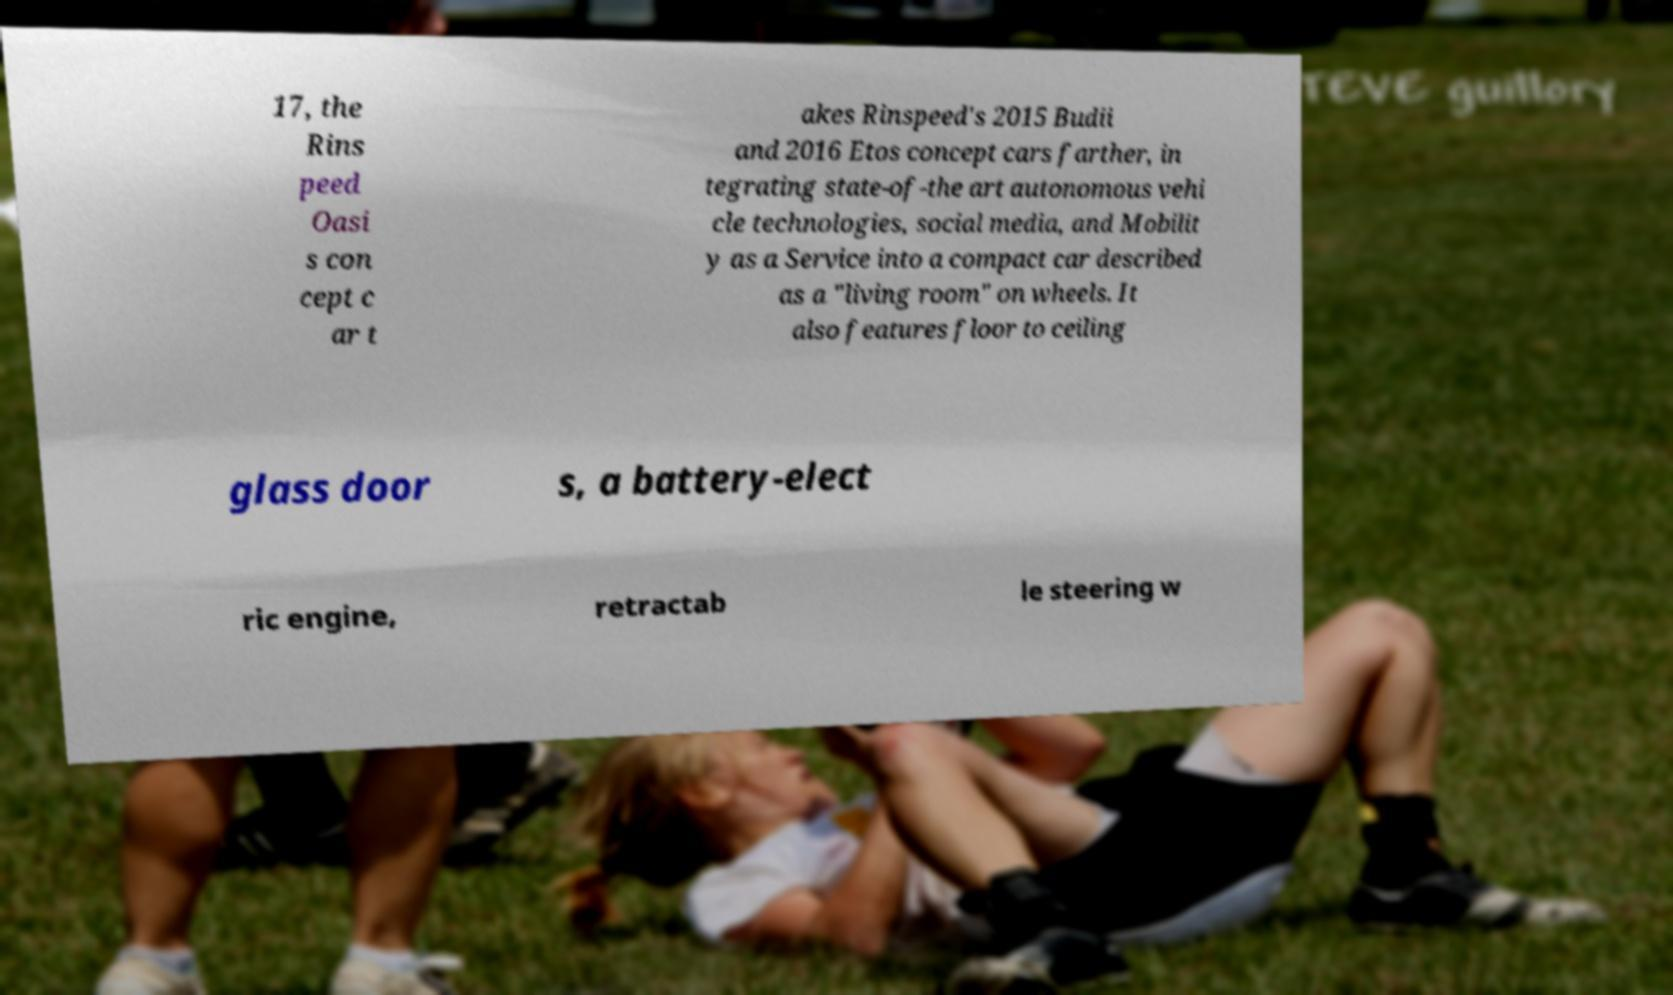Please identify and transcribe the text found in this image. 17, the Rins peed Oasi s con cept c ar t akes Rinspeed's 2015 Budii and 2016 Etos concept cars farther, in tegrating state-of-the art autonomous vehi cle technologies, social media, and Mobilit y as a Service into a compact car described as a "living room" on wheels. It also features floor to ceiling glass door s, a battery-elect ric engine, retractab le steering w 